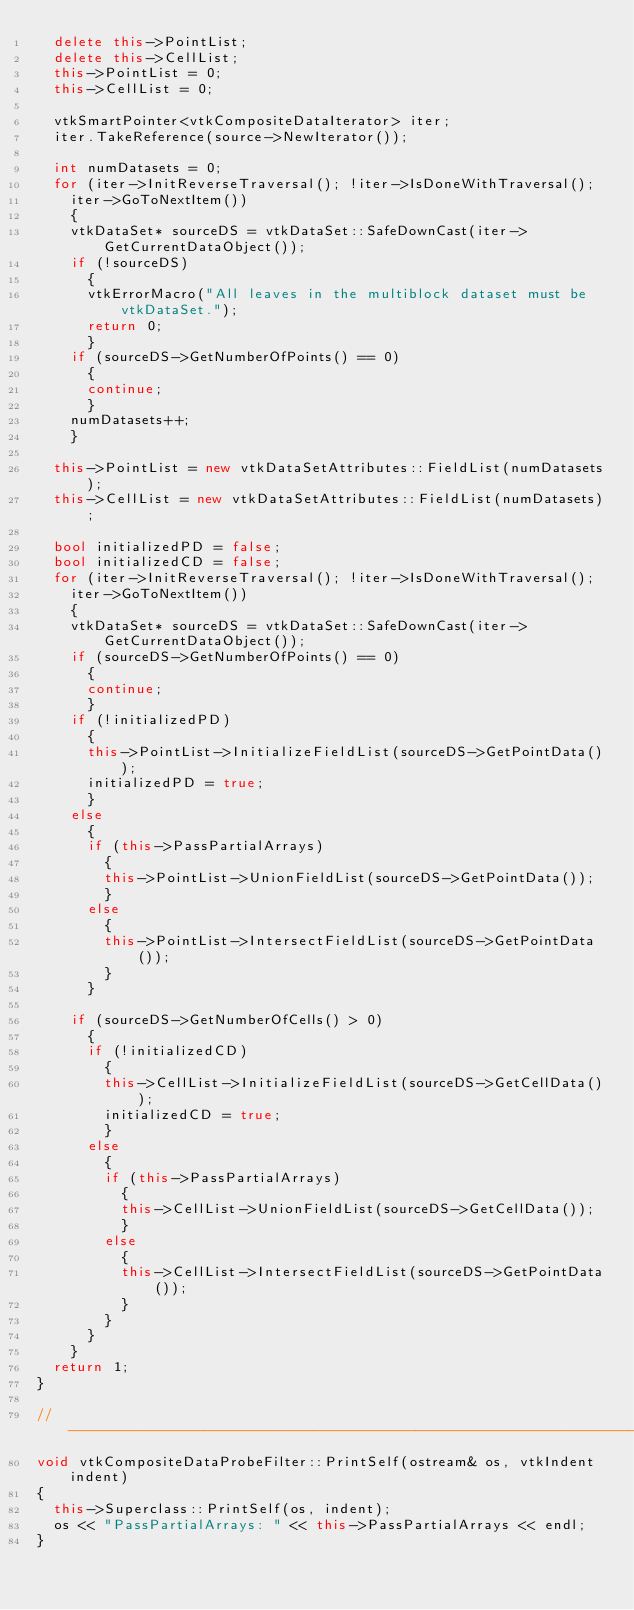<code> <loc_0><loc_0><loc_500><loc_500><_C++_>  delete this->PointList;
  delete this->CellList;
  this->PointList = 0;
  this->CellList = 0;

  vtkSmartPointer<vtkCompositeDataIterator> iter;
  iter.TakeReference(source->NewIterator());

  int numDatasets = 0;
  for (iter->InitReverseTraversal(); !iter->IsDoneWithTraversal();
    iter->GoToNextItem())
    {
    vtkDataSet* sourceDS = vtkDataSet::SafeDownCast(iter->GetCurrentDataObject());
    if (!sourceDS)
      {
      vtkErrorMacro("All leaves in the multiblock dataset must be vtkDataSet.");
      return 0;
      }
    if (sourceDS->GetNumberOfPoints() == 0)
      {
      continue;
      }
    numDatasets++;
    }

  this->PointList = new vtkDataSetAttributes::FieldList(numDatasets);
  this->CellList = new vtkDataSetAttributes::FieldList(numDatasets);

  bool initializedPD = false;
  bool initializedCD = false;
  for (iter->InitReverseTraversal(); !iter->IsDoneWithTraversal();
    iter->GoToNextItem())
    {
    vtkDataSet* sourceDS = vtkDataSet::SafeDownCast(iter->GetCurrentDataObject());
    if (sourceDS->GetNumberOfPoints() == 0)
      {
      continue;
      }
    if (!initializedPD)
      {
      this->PointList->InitializeFieldList(sourceDS->GetPointData());
      initializedPD = true;
      }
    else
      {
      if (this->PassPartialArrays)
        {
        this->PointList->UnionFieldList(sourceDS->GetPointData());
        }
      else
        {
        this->PointList->IntersectFieldList(sourceDS->GetPointData());
        }
      }

    if (sourceDS->GetNumberOfCells() > 0)
      {
      if (!initializedCD)
        {
        this->CellList->InitializeFieldList(sourceDS->GetCellData());
        initializedCD = true;
        }
      else
        {
        if (this->PassPartialArrays)
          {
          this->CellList->UnionFieldList(sourceDS->GetCellData());
          }
        else
          {
          this->CellList->IntersectFieldList(sourceDS->GetPointData());
          }
        }
      }
    }
  return 1;
}

//----------------------------------------------------------------------------
void vtkCompositeDataProbeFilter::PrintSelf(ostream& os, vtkIndent indent)
{
  this->Superclass::PrintSelf(os, indent);
  os << "PassPartialArrays: " << this->PassPartialArrays << endl;
}

</code> 